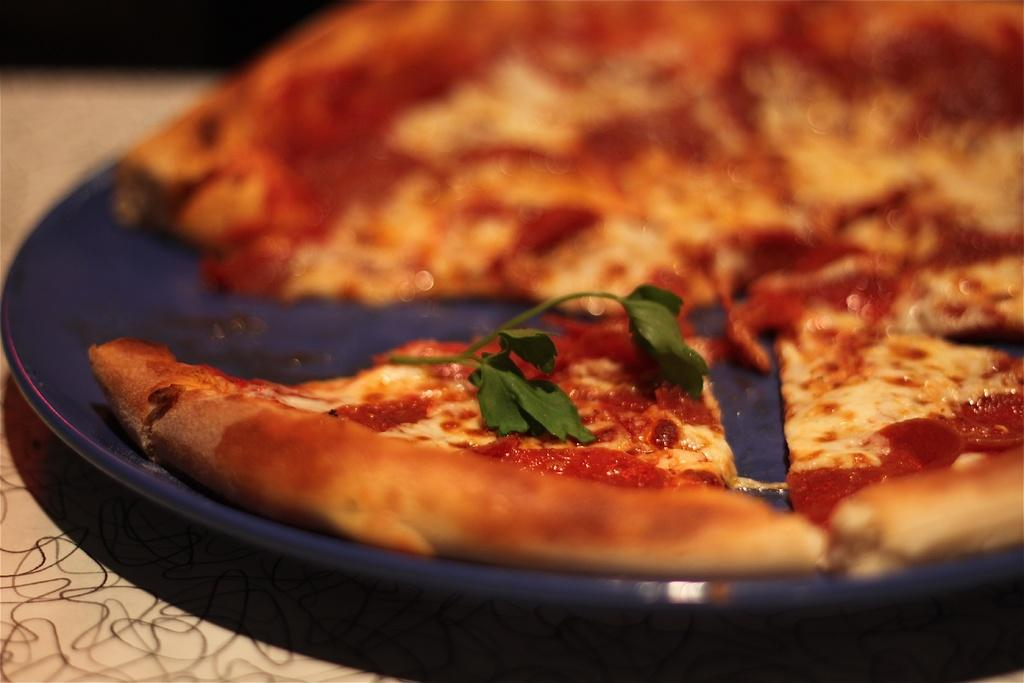What type of food is the main subject of the image? There is a pizza in the image. How is the pizza presented in the image? The pizza is in a plate. Where is the plate with pizza located? The plate with pizza is placed on a table. What type of earth can be seen in the image? There is no earth visible in the image; it features a pizza in a plate on a table. 